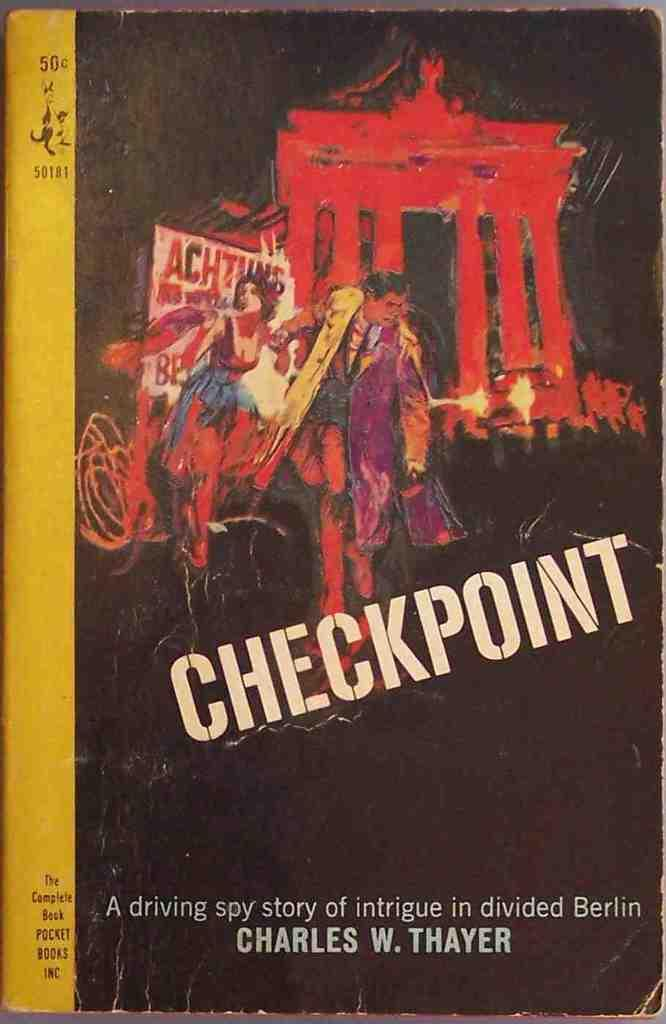<image>
Render a clear and concise summary of the photo. A book called checkpoint with a dramatic art on the front 